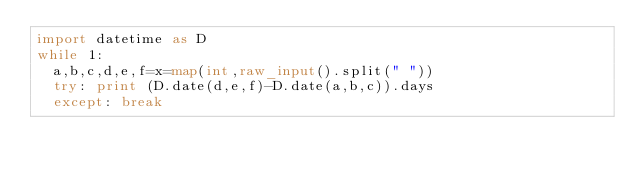Convert code to text. <code><loc_0><loc_0><loc_500><loc_500><_Python_>import datetime as D
while 1:
  a,b,c,d,e,f=x=map(int,raw_input().split(" "))
  try: print (D.date(d,e,f)-D.date(a,b,c)).days
  except: break</code> 